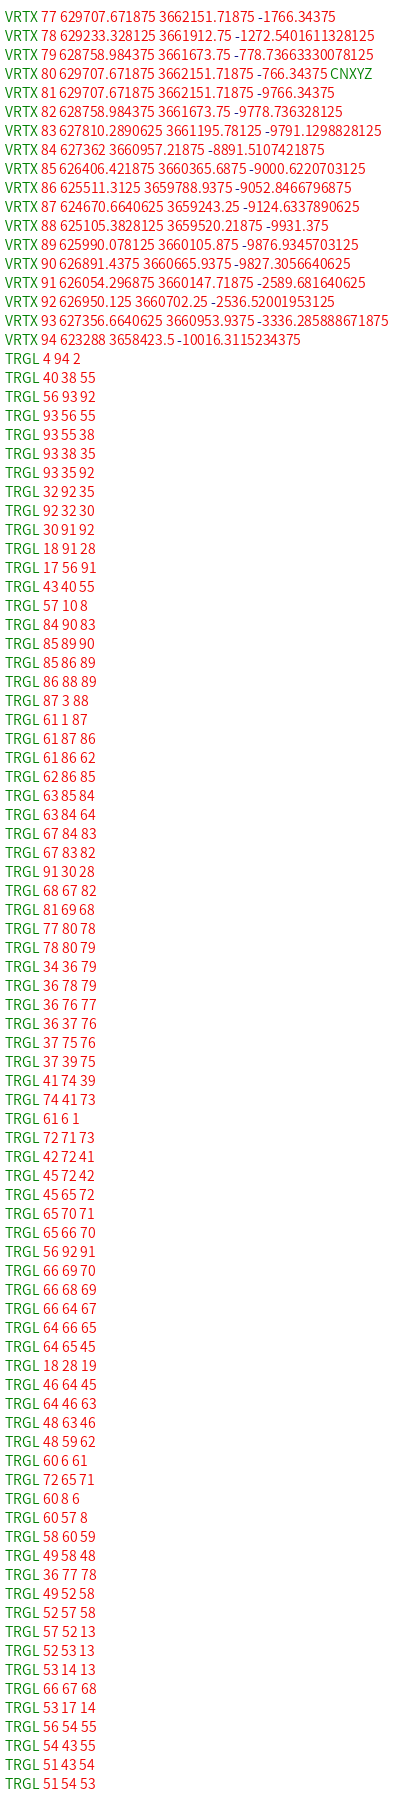Convert code to text. <code><loc_0><loc_0><loc_500><loc_500><_TypeScript_>VRTX 77 629707.671875 3662151.71875 -1766.34375 
VRTX 78 629233.328125 3661912.75 -1272.5401611328125 
VRTX 79 628758.984375 3661673.75 -778.73663330078125 
VRTX 80 629707.671875 3662151.71875 -766.34375 CNXYZ
VRTX 81 629707.671875 3662151.71875 -9766.34375 
VRTX 82 628758.984375 3661673.75 -9778.736328125 
VRTX 83 627810.2890625 3661195.78125 -9791.1298828125 
VRTX 84 627362 3660957.21875 -8891.5107421875 
VRTX 85 626406.421875 3660365.6875 -9000.6220703125 
VRTX 86 625511.3125 3659788.9375 -9052.8466796875 
VRTX 87 624670.6640625 3659243.25 -9124.6337890625 
VRTX 88 625105.3828125 3659520.21875 -9931.375 
VRTX 89 625990.078125 3660105.875 -9876.9345703125 
VRTX 90 626891.4375 3660665.9375 -9827.3056640625 
VRTX 91 626054.296875 3660147.71875 -2589.681640625 
VRTX 92 626950.125 3660702.25 -2536.52001953125 
VRTX 93 627356.6640625 3660953.9375 -3336.285888671875 
VRTX 94 623288 3658423.5 -10016.3115234375 
TRGL 4 94 2 
TRGL 40 38 55 
TRGL 56 93 92 
TRGL 93 56 55 
TRGL 93 55 38 
TRGL 93 38 35 
TRGL 93 35 92 
TRGL 32 92 35 
TRGL 92 32 30 
TRGL 30 91 92 
TRGL 18 91 28 
TRGL 17 56 91 
TRGL 43 40 55 
TRGL 57 10 8 
TRGL 84 90 83 
TRGL 85 89 90 
TRGL 85 86 89 
TRGL 86 88 89 
TRGL 87 3 88 
TRGL 61 1 87 
TRGL 61 87 86 
TRGL 61 86 62 
TRGL 62 86 85 
TRGL 63 85 84 
TRGL 63 84 64 
TRGL 67 84 83 
TRGL 67 83 82 
TRGL 91 30 28 
TRGL 68 67 82 
TRGL 81 69 68 
TRGL 77 80 78 
TRGL 78 80 79 
TRGL 34 36 79 
TRGL 36 78 79 
TRGL 36 76 77 
TRGL 36 37 76 
TRGL 37 75 76 
TRGL 37 39 75 
TRGL 41 74 39 
TRGL 74 41 73 
TRGL 61 6 1 
TRGL 72 71 73 
TRGL 42 72 41 
TRGL 45 72 42 
TRGL 45 65 72 
TRGL 65 70 71 
TRGL 65 66 70 
TRGL 56 92 91 
TRGL 66 69 70 
TRGL 66 68 69 
TRGL 66 64 67 
TRGL 64 66 65 
TRGL 64 65 45 
TRGL 18 28 19 
TRGL 46 64 45 
TRGL 64 46 63 
TRGL 48 63 46 
TRGL 48 59 62 
TRGL 60 6 61 
TRGL 72 65 71 
TRGL 60 8 6 
TRGL 60 57 8 
TRGL 58 60 59 
TRGL 49 58 48 
TRGL 36 77 78 
TRGL 49 52 58 
TRGL 52 57 58 
TRGL 57 52 13 
TRGL 52 53 13 
TRGL 53 14 13 
TRGL 66 67 68 
TRGL 53 17 14 
TRGL 56 54 55 
TRGL 54 43 55 
TRGL 51 43 54 
TRGL 51 54 53 </code> 